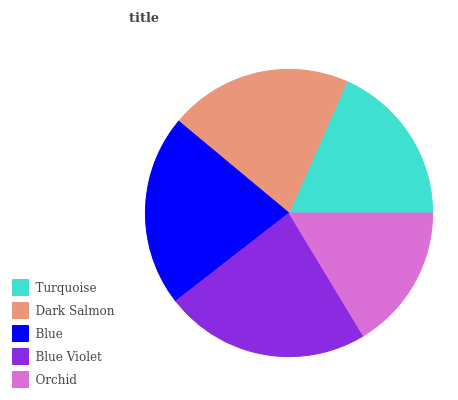Is Orchid the minimum?
Answer yes or no. Yes. Is Blue Violet the maximum?
Answer yes or no. Yes. Is Dark Salmon the minimum?
Answer yes or no. No. Is Dark Salmon the maximum?
Answer yes or no. No. Is Dark Salmon greater than Turquoise?
Answer yes or no. Yes. Is Turquoise less than Dark Salmon?
Answer yes or no. Yes. Is Turquoise greater than Dark Salmon?
Answer yes or no. No. Is Dark Salmon less than Turquoise?
Answer yes or no. No. Is Dark Salmon the high median?
Answer yes or no. Yes. Is Dark Salmon the low median?
Answer yes or no. Yes. Is Blue Violet the high median?
Answer yes or no. No. Is Blue Violet the low median?
Answer yes or no. No. 